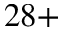Convert formula to latex. <formula><loc_0><loc_0><loc_500><loc_500>{ 2 8 + }</formula> 